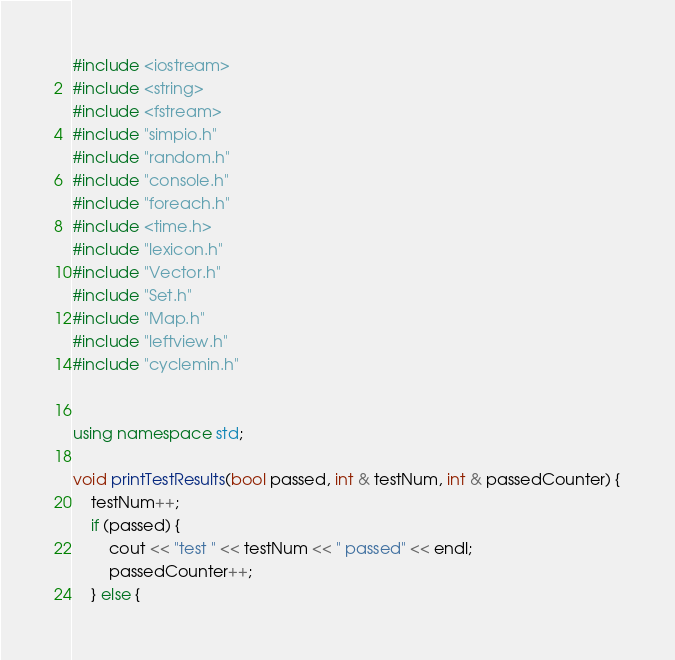Convert code to text. <code><loc_0><loc_0><loc_500><loc_500><_C++_>#include <iostream>
#include <string>
#include <fstream>
#include "simpio.h"
#include "random.h"
#include "console.h"
#include "foreach.h"
#include <time.h>
#include "lexicon.h"
#include "Vector.h"
#include "Set.h"
#include "Map.h"
#include "leftview.h"
#include "cyclemin.h"


using namespace std;

void printTestResults(bool passed, int & testNum, int & passedCounter) {
	testNum++;
	if (passed) {
		cout << "test " << testNum << " passed" << endl;
		passedCounter++;
	} else {</code> 